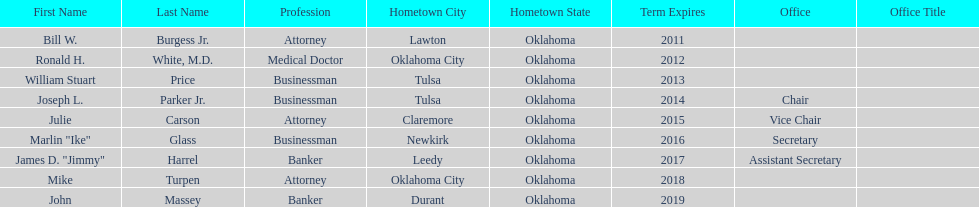How many members had businessman listed as their profession? 3. 